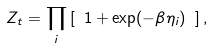<formula> <loc_0><loc_0><loc_500><loc_500>Z _ { t } = \prod _ { i } \left [ \ 1 + \exp ( - \beta \eta _ { i } ) \ \right ] ,</formula> 